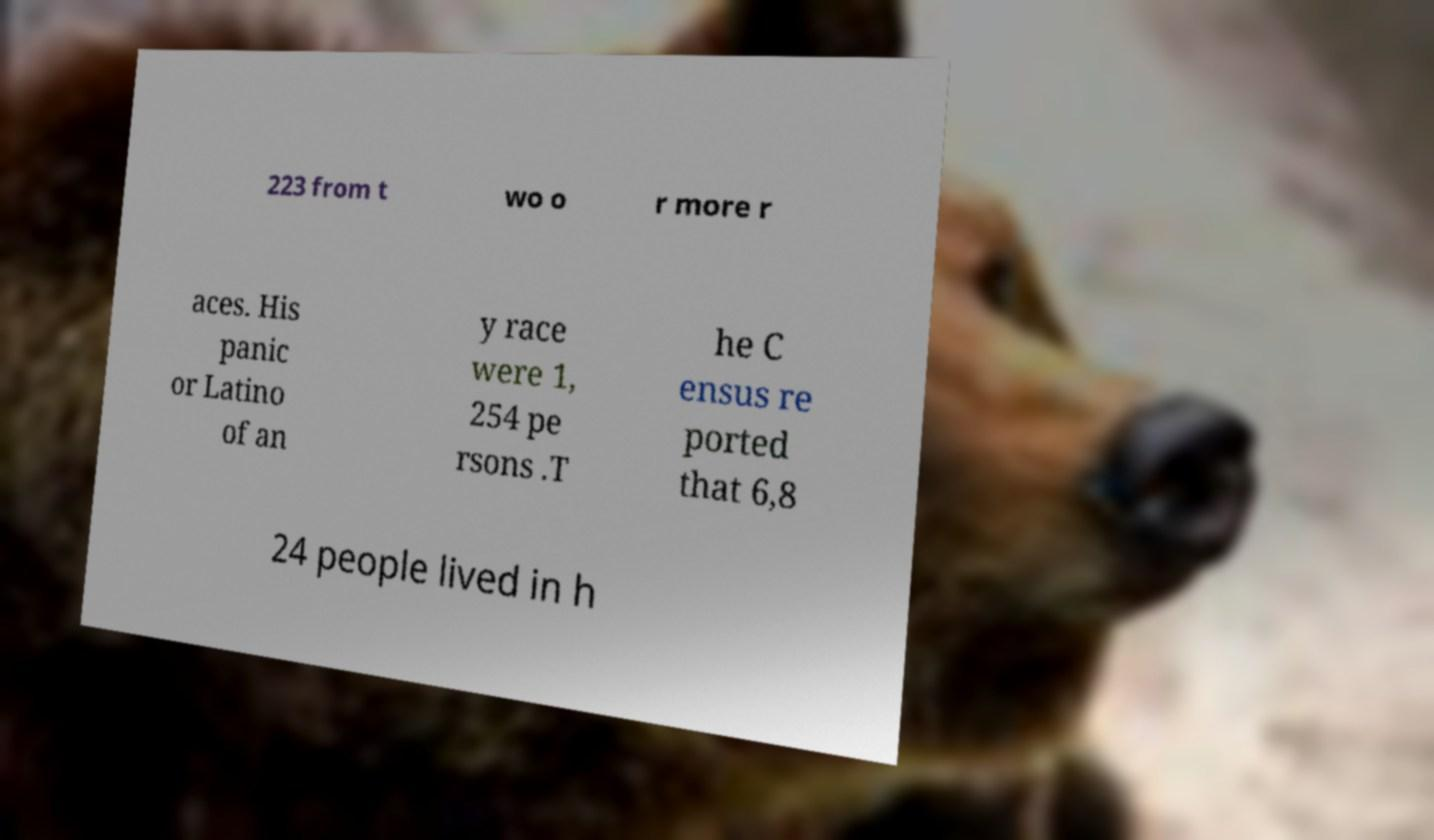Could you assist in decoding the text presented in this image and type it out clearly? 223 from t wo o r more r aces. His panic or Latino of an y race were 1, 254 pe rsons .T he C ensus re ported that 6,8 24 people lived in h 